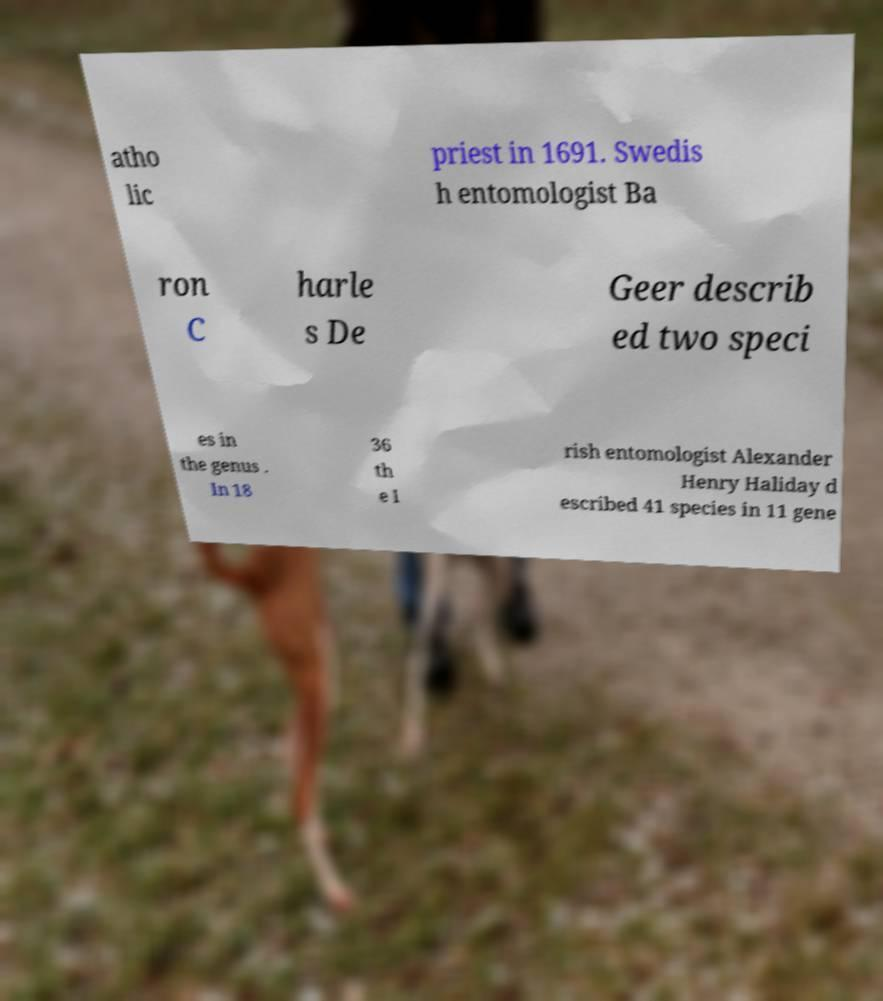Could you assist in decoding the text presented in this image and type it out clearly? atho lic priest in 1691. Swedis h entomologist Ba ron C harle s De Geer describ ed two speci es in the genus . In 18 36 th e I rish entomologist Alexander Henry Haliday d escribed 41 species in 11 gene 